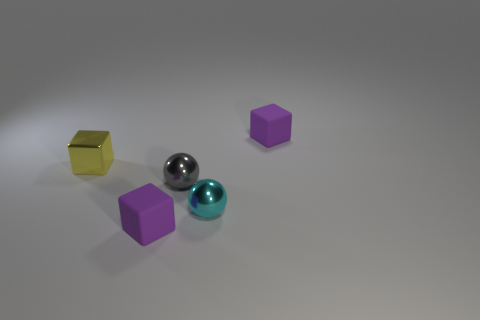What textures can be observed on the surfaces in the image? The surfaces in the image exhibit a variety of textures. The floor has a smooth, slightly reflective finish, the yellow block appears to have a matte texture, and the metallic object has a shiny, reflective surface. The purple cubes and the cyan spheres also have smooth surfaces with different shades and reflections. 